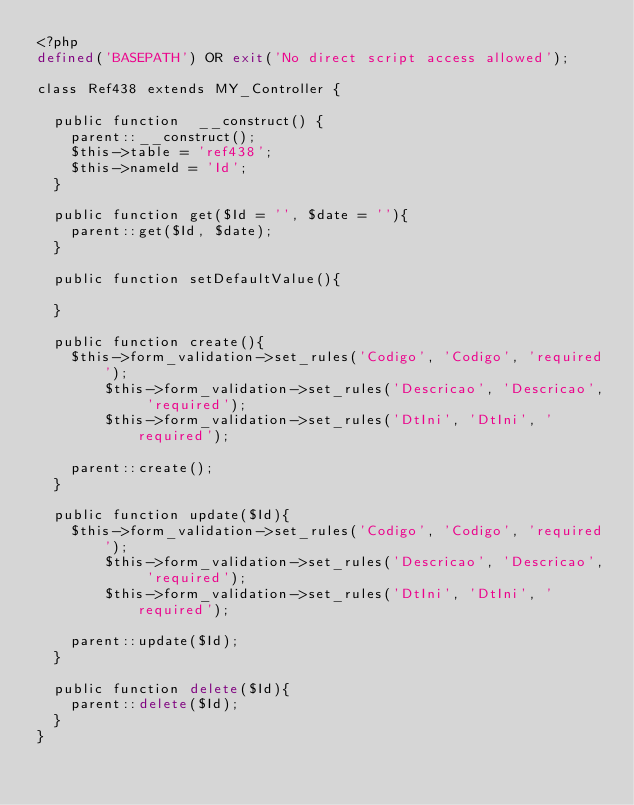<code> <loc_0><loc_0><loc_500><loc_500><_PHP_><?php
defined('BASEPATH') OR exit('No direct script access allowed');

class Ref438 extends MY_Controller {

  public function  __construct() {
    parent::__construct();
    $this->table = 'ref438';
    $this->nameId = 'Id';
  }

  public function get($Id = '', $date = ''){
    parent::get($Id, $date);
  }
  
  public function setDefaultValue(){
    
  }

  public function create(){
    $this->form_validation->set_rules('Codigo', 'Codigo', 'required');
		$this->form_validation->set_rules('Descricao', 'Descricao', 'required');
		$this->form_validation->set_rules('DtIni', 'DtIni', 'required');
		
    parent::create();
  }
  
  public function update($Id){
    $this->form_validation->set_rules('Codigo', 'Codigo', 'required');
		$this->form_validation->set_rules('Descricao', 'Descricao', 'required');
		$this->form_validation->set_rules('DtIni', 'DtIni', 'required');
		
    parent::update($Id);
  }

  public function delete($Id){
    parent::delete($Id);
  }
}</code> 